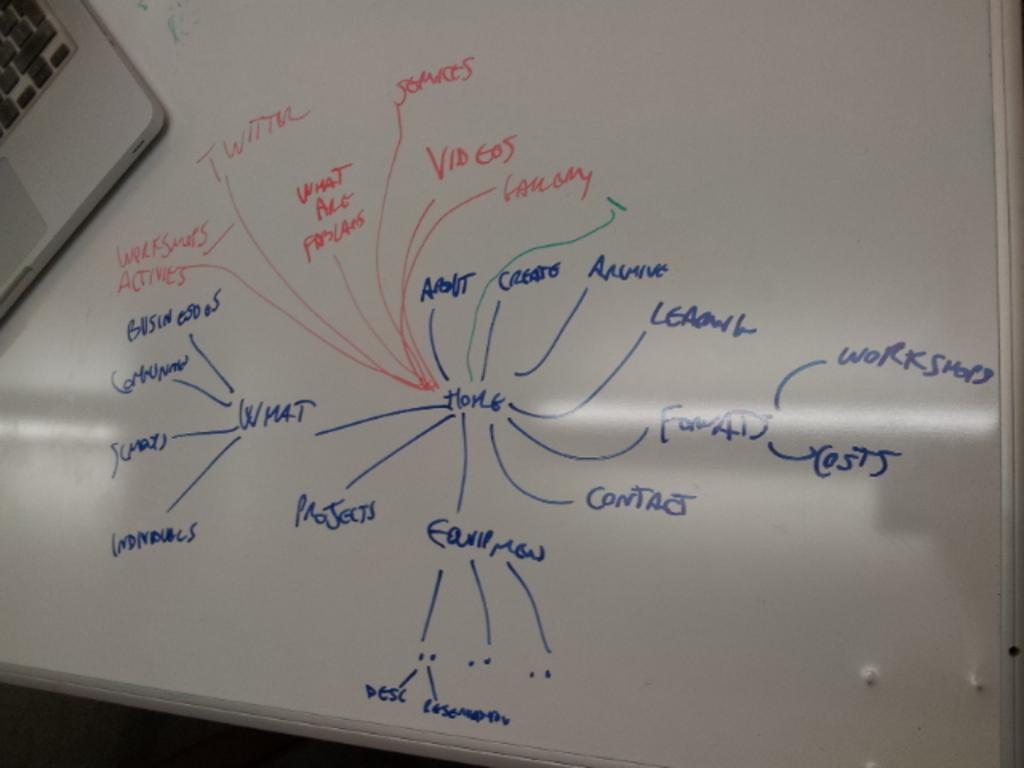What is the focal point of the brainstorming process?
Make the answer very short. Home. What word is above "costs?"?
Make the answer very short. Workshops. 